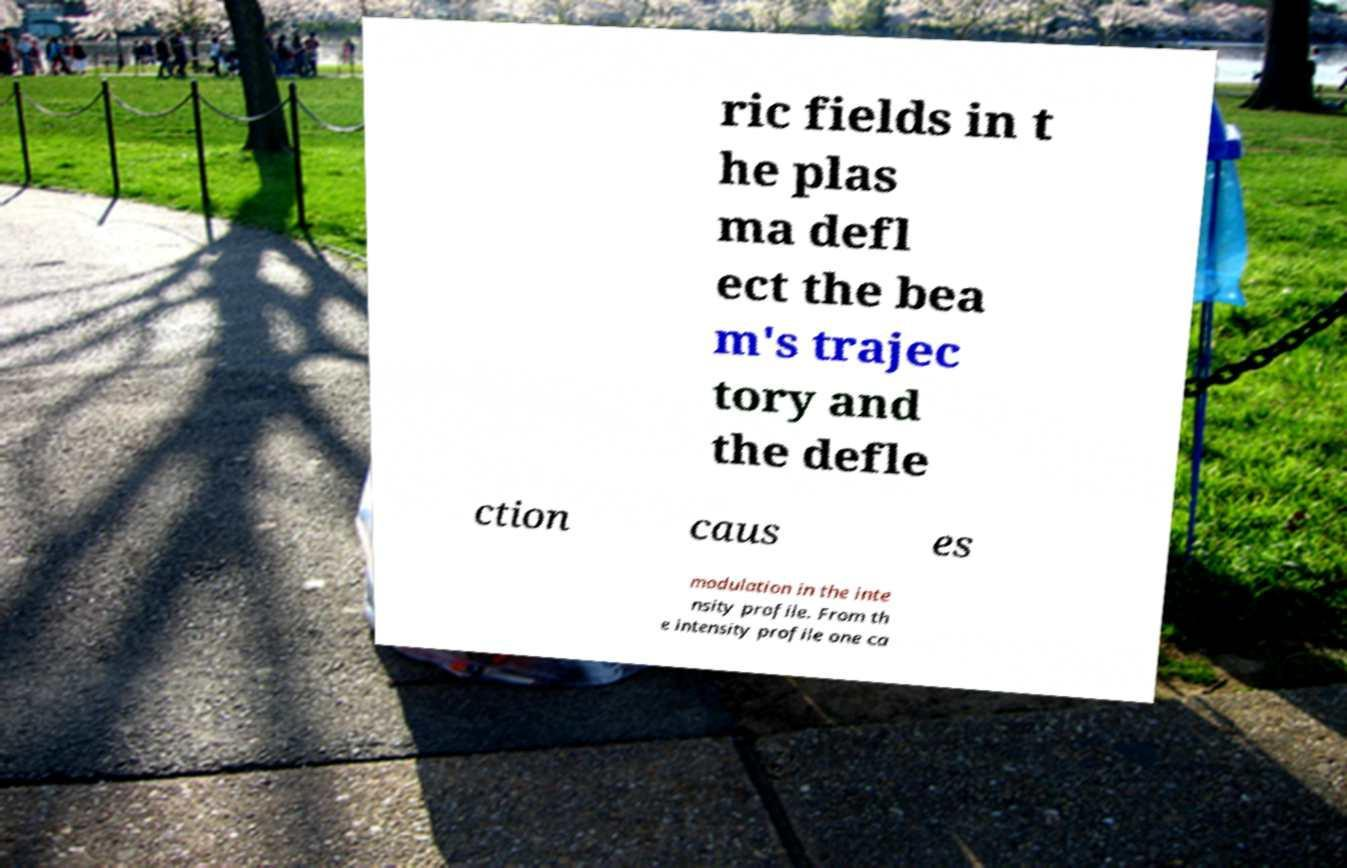Please identify and transcribe the text found in this image. ric fields in t he plas ma defl ect the bea m's trajec tory and the defle ction caus es modulation in the inte nsity profile. From th e intensity profile one ca 